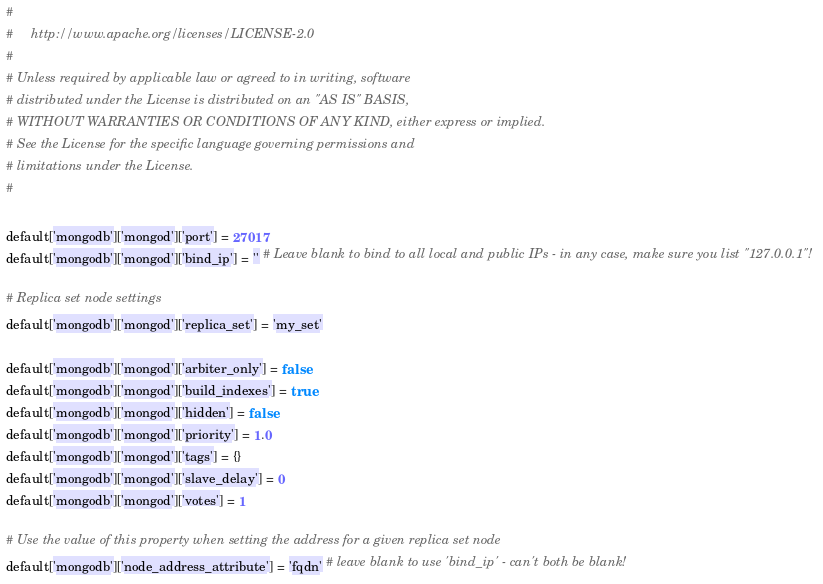Convert code to text. <code><loc_0><loc_0><loc_500><loc_500><_Ruby_>#
#     http://www.apache.org/licenses/LICENSE-2.0
#
# Unless required by applicable law or agreed to in writing, software
# distributed under the License is distributed on an "AS IS" BASIS,
# WITHOUT WARRANTIES OR CONDITIONS OF ANY KIND, either express or implied.
# See the License for the specific language governing permissions and
# limitations under the License.
#

default['mongodb']['mongod']['port'] = 27017
default['mongodb']['mongod']['bind_ip'] = '' # Leave blank to bind to all local and public IPs - in any case, make sure you list "127.0.0.1"!

# Replica set node settings
default['mongodb']['mongod']['replica_set'] = 'my_set'

default['mongodb']['mongod']['arbiter_only'] = false
default['mongodb']['mongod']['build_indexes'] = true
default['mongodb']['mongod']['hidden'] = false
default['mongodb']['mongod']['priority'] = 1.0
default['mongodb']['mongod']['tags'] = {}
default['mongodb']['mongod']['slave_delay'] = 0
default['mongodb']['mongod']['votes'] = 1

# Use the value of this property when setting the address for a given replica set node
default['mongodb']['node_address_attribute'] = 'fqdn' # leave blank to use 'bind_ip' - can't both be blank!</code> 